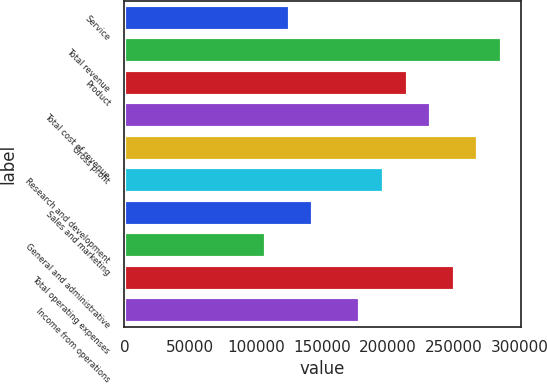Convert chart to OTSL. <chart><loc_0><loc_0><loc_500><loc_500><bar_chart><fcel>Service<fcel>Total revenue<fcel>Product<fcel>Total cost of revenue<fcel>Gross profit<fcel>Research and development<fcel>Sales and marketing<fcel>General and administrative<fcel>Total operating expenses<fcel>Income from operations<nl><fcel>125332<fcel>286472<fcel>214854<fcel>232758<fcel>268567<fcel>196950<fcel>143236<fcel>107427<fcel>250663<fcel>179045<nl></chart> 